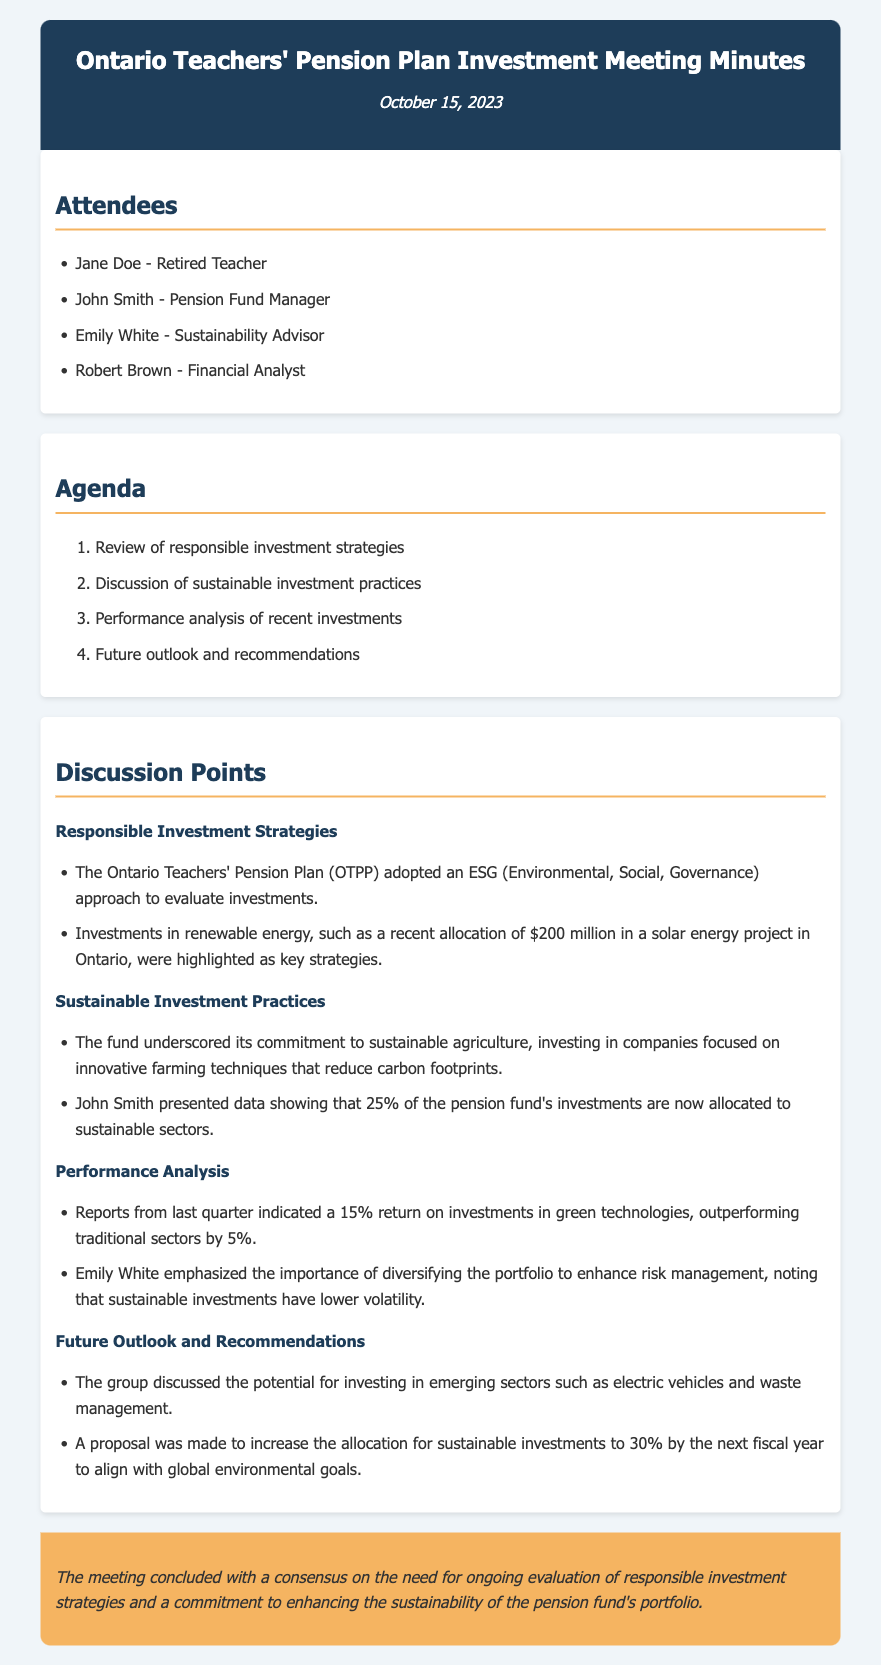what is the date of the meeting? The date is provided in the header section of the document, which states October 15, 2023.
Answer: October 15, 2023 who is the Pension Fund Manager? The document lists the attendees, indicating that John Smith is the Pension Fund Manager.
Answer: John Smith how much was allocated to the solar energy project? The document mentions a specific investment amount in the discussion on responsible investment strategies, which is $200 million.
Answer: $200 million what percentage of investments are allocated to sustainable sectors? In the section on Sustainable Investment Practices, it is stated that 25% of the pension fund's investments are now allocated to sustainable sectors.
Answer: 25% what was the return on investments in green technologies last quarter? The performance analysis indicates a specific return rate, which is 15%.
Answer: 15% what sectors are discussed for potential future investments? The future outlook includes discussions on several sectors, particularly electric vehicles and waste management.
Answer: electric vehicles and waste management who emphasized the importance of diversifying the portfolio? The document mentions Emily White, who is identified as the Sustainability Advisor, as emphasizing this importance.
Answer: Emily White what is the proposed allocation for sustainable investments by the next fiscal year? The document references a proposal to increase the allocation to sustainable investments to 30%.
Answer: 30% 